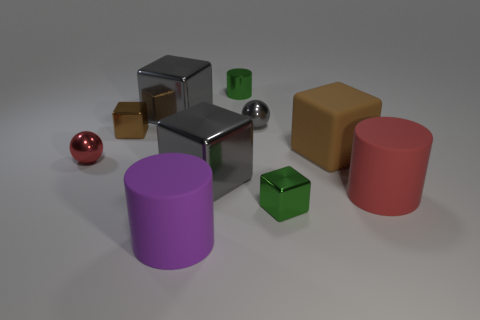Subtract all large brown blocks. How many blocks are left? 4 Subtract all green cubes. How many cubes are left? 4 Subtract all red blocks. Subtract all cyan balls. How many blocks are left? 5 Subtract all cylinders. How many objects are left? 7 Subtract all large brown rubber blocks. Subtract all large blue matte cubes. How many objects are left? 9 Add 3 tiny spheres. How many tiny spheres are left? 5 Add 10 tiny red cubes. How many tiny red cubes exist? 10 Subtract 1 gray spheres. How many objects are left? 9 